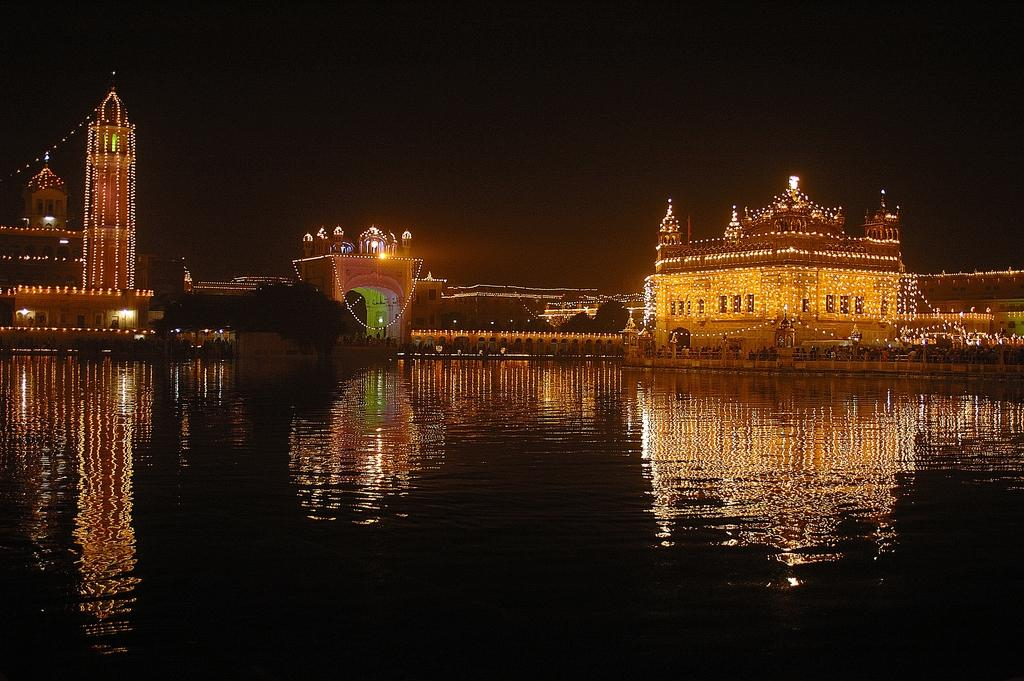What is the primary element visible in the image? There is water in the image. What type of structures can be seen in the image? There are buildings in the image. How are the buildings decorated? The buildings have lights as decoration. Can you describe the overall lighting in the image? The image appears to be slightly dark. What type of footwear is being advertised in the image? There is no footwear or advertisement present in the image; it features water and buildings with lights. Can you tell me what type of guitar is being played in the image? There is no guitar present in the image. 